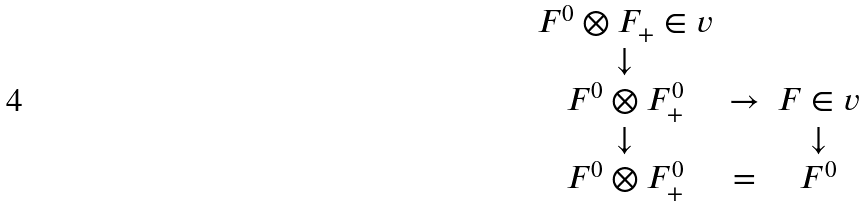Convert formula to latex. <formula><loc_0><loc_0><loc_500><loc_500>\begin{matrix} F ^ { 0 } \otimes F _ { + } \in v & & \\ \downarrow & & \\ F ^ { 0 } \otimes F ^ { 0 } _ { + } & \to & F \in v \\ \downarrow & & \downarrow \\ F ^ { 0 } \otimes F ^ { 0 } _ { + } & = & F ^ { 0 } \end{matrix}</formula> 